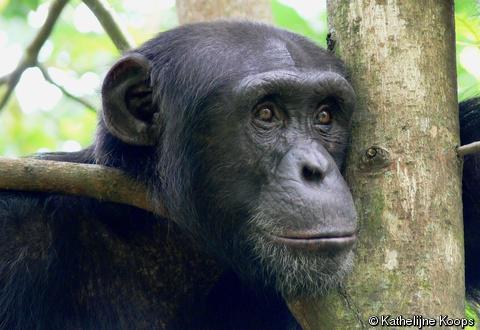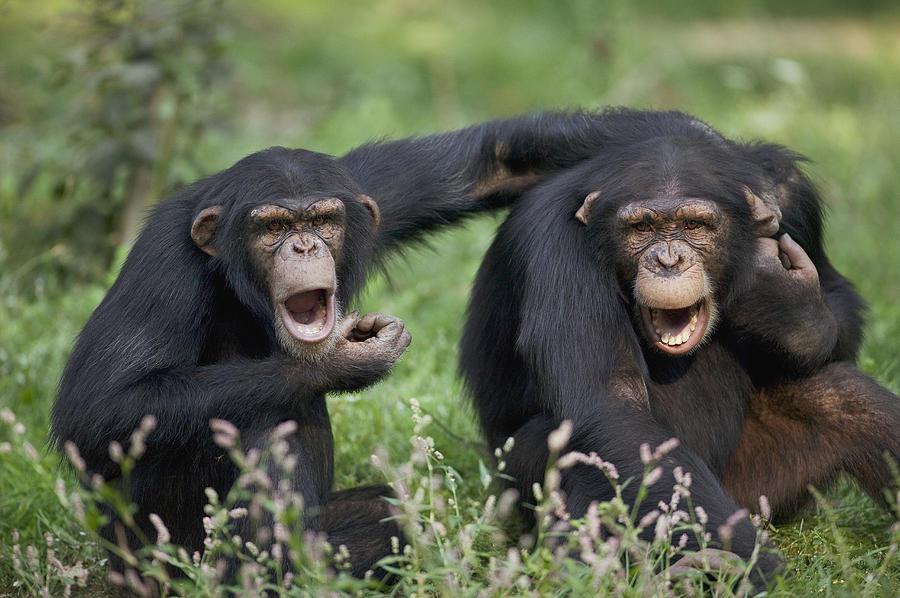The first image is the image on the left, the second image is the image on the right. For the images shown, is this caption "The right image contains exactly one chimpanzee." true? Answer yes or no. No. The first image is the image on the left, the second image is the image on the right. Given the left and right images, does the statement "One image includes exactly twice as many chimps as the other image." hold true? Answer yes or no. Yes. 